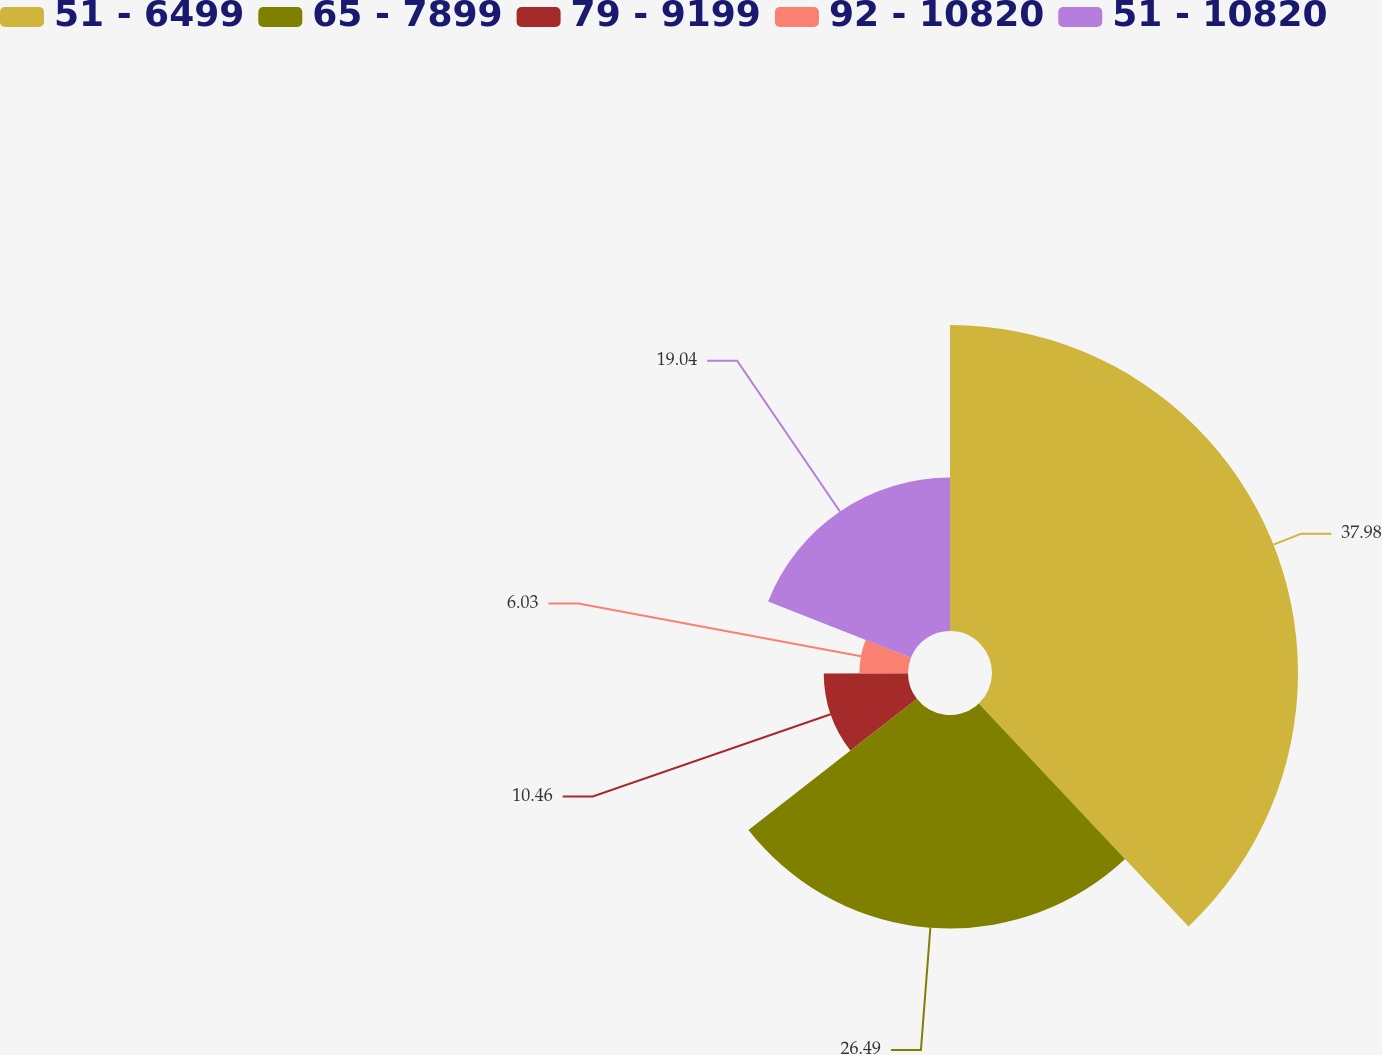Convert chart to OTSL. <chart><loc_0><loc_0><loc_500><loc_500><pie_chart><fcel>51 - 6499<fcel>65 - 7899<fcel>79 - 9199<fcel>92 - 10820<fcel>51 - 10820<nl><fcel>37.98%<fcel>26.49%<fcel>10.46%<fcel>6.03%<fcel>19.04%<nl></chart> 